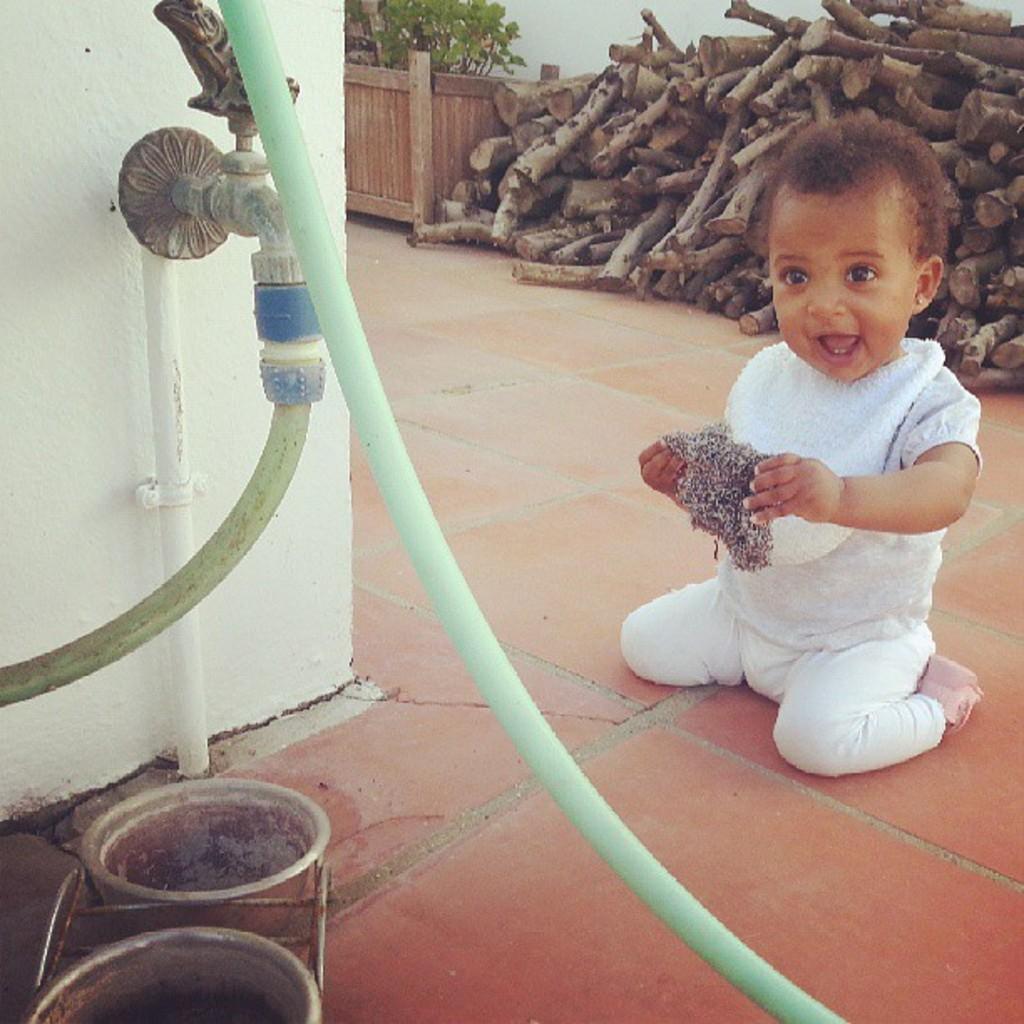Please provide a concise description of this image. This kid is holding an object. Here we can see a tap, pipes and object. Background there is a plant and wooden logs.  